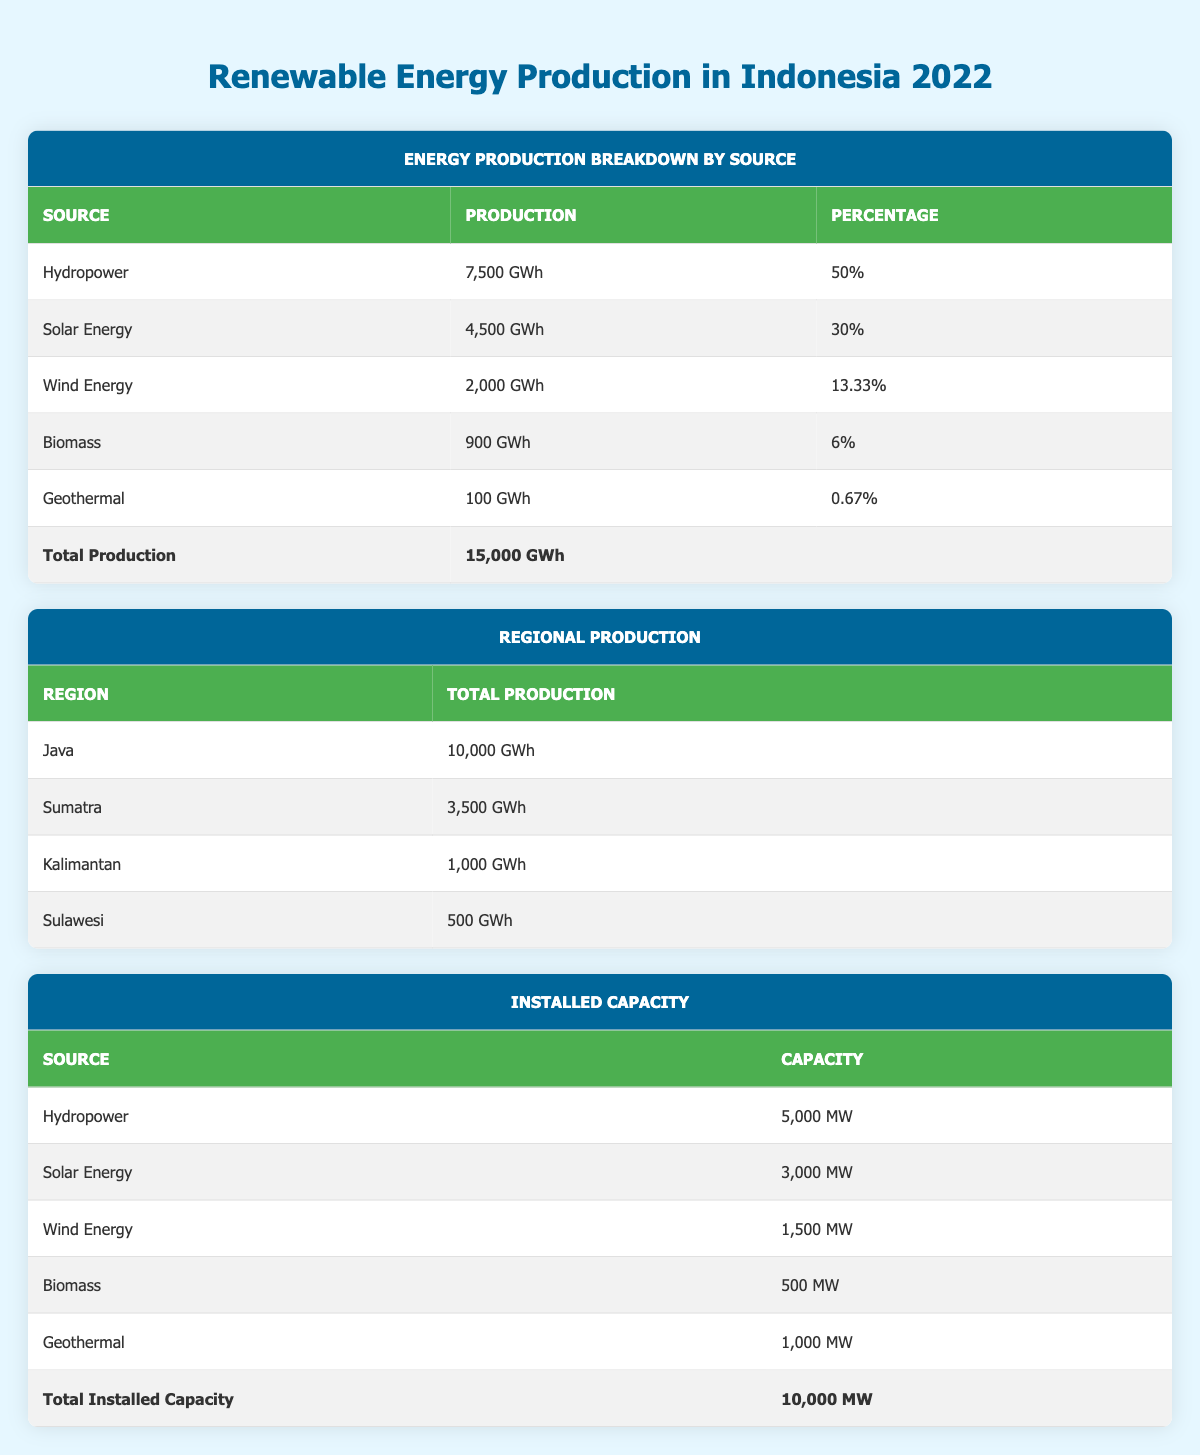What is the total production of renewable energy in Indonesia for 2022? The total production of renewable energy is listed directly under the "Total Production" section of the table, which states "15,000 GWh".
Answer: 15,000 GWh What percentage of the total renewable energy production comes from solar energy? The table shows that solar energy contributes "4,500 GWh", which is "30%" of the total production. This percentage is explicitly stated in the breakdown by source.
Answer: 30% Which renewable energy source produced the least amount of energy in 2022? In the breakdown of production by source, geothermal is listed with "100 GWh", which is the lowest production value compared to the other sources.
Answer: Geothermal What is the combined production of hydropower and biomass energy in 2022? Hydropower production is "7,500 GWh" and biomass production is "900 GWh". Adding these values gives: 7,500 GWh + 900 GWh = 8,400 GWh.
Answer: 8,400 GWh Is it true that Java produced more energy than the combined total of Sumatra, Kalimantan, and Sulawesi? The production values show that Java produced "10,000 GWh" while the combined production of Sumatra (3,500 GWh), Kalimantan (1,000 GWh), and Sulawesi (500 GWh) totals 5,000 GWh (3,500 + 1,000 + 500 = 5,000 GWh). Since 10,000 GWh is greater than 5,000 GWh, the statement is true.
Answer: Yes What region produced exactly 1,000 GWh of renewable energy in 2022? Referring to the regional production table, Kalimantan is the region listed with total production of "1,000 GWh".
Answer: Kalimantan What is the total installed capacity of renewable energy sources in Indonesia? The total installed capacity is stated in the table as "10,000 MW" under the Installed Capacity section.
Answer: 10,000 MW How much more energy does hydropower produce than wind energy? Hydropower produces "7,500 GWh" and wind energy produces "2,000 GWh". The difference is calculated as: 7,500 GWh - 2,000 GWh = 5,500 GWh.
Answer: 5,500 GWh What is the total production of renewable energy from sources other than solar and hydropower? The total production for other sources includes wind (2,000 GWh), biomass (900 GWh), and geothermal (100 GWh). Adding these gives: 2,000 GWh + 900 GWh + 100 GWh = 3,000 GWh.
Answer: 3,000 GWh 